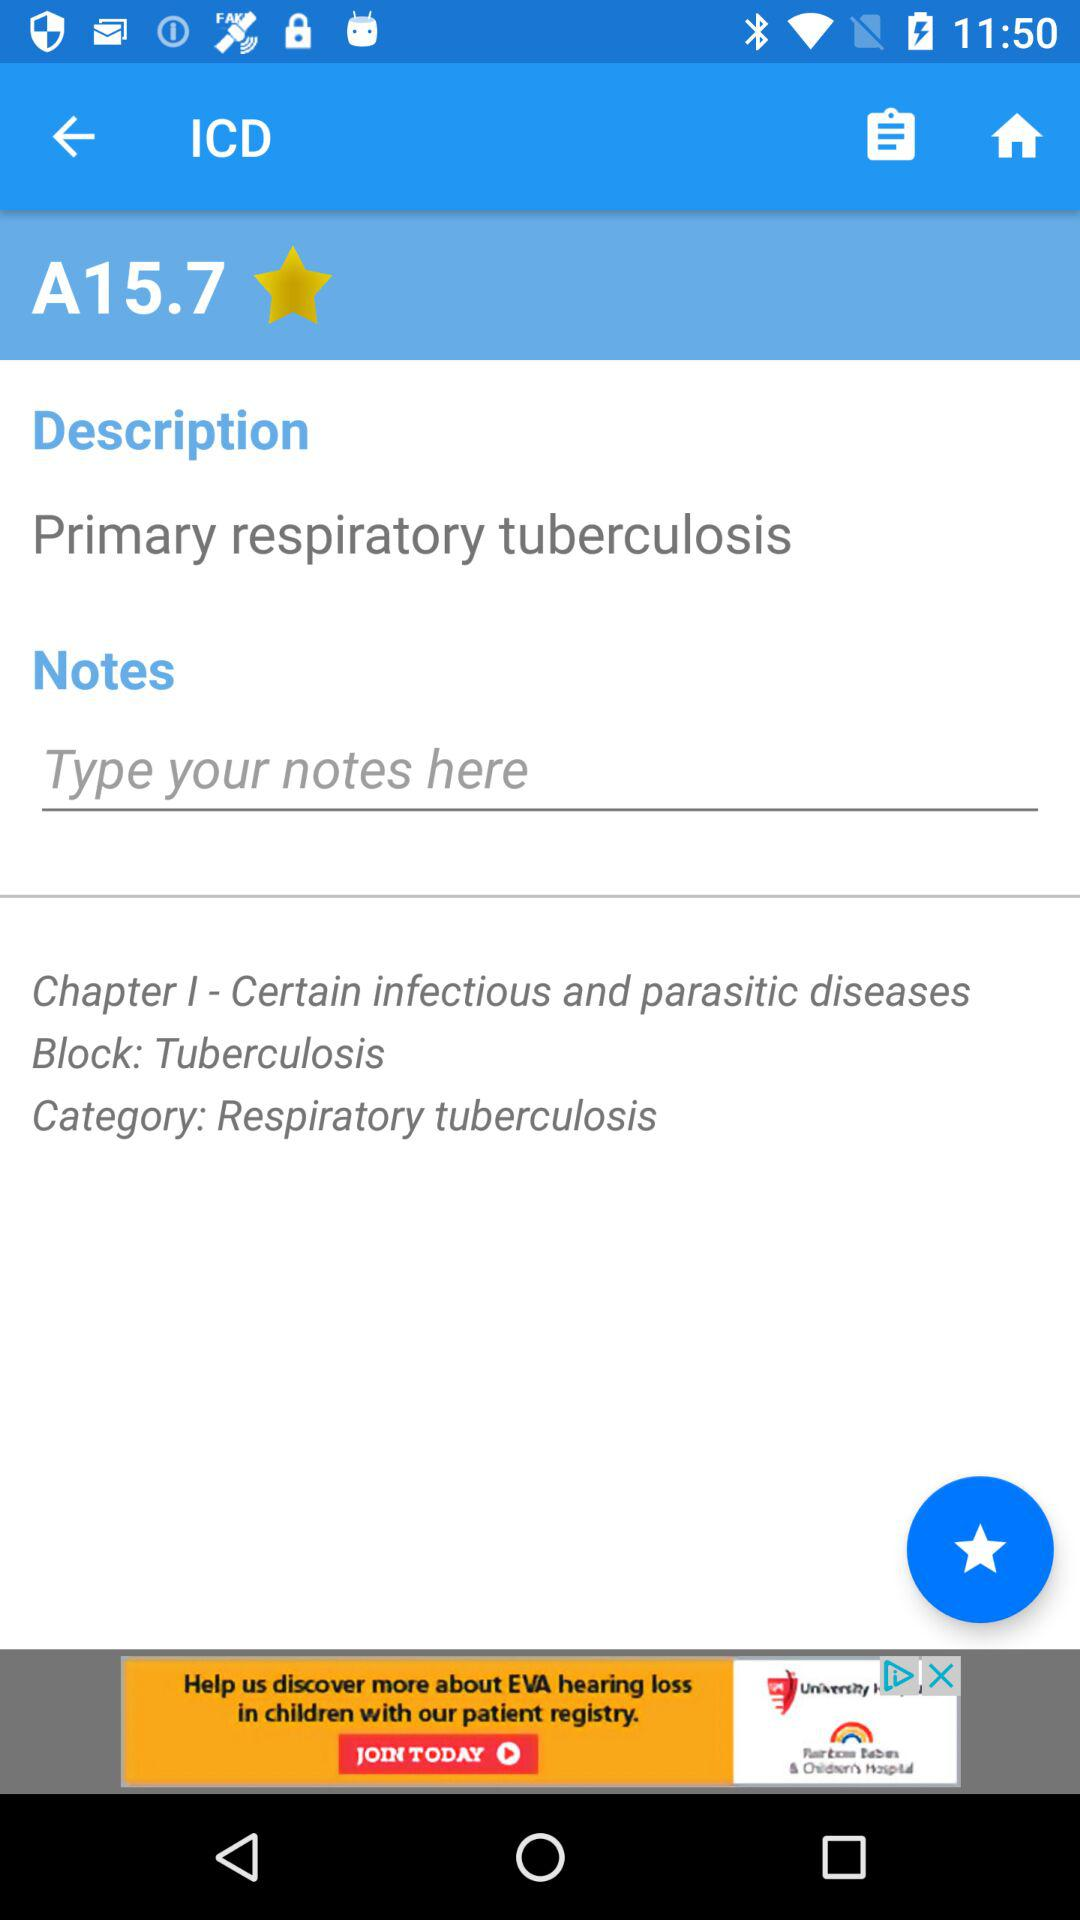What is the category? The category is "Respiratory tuberculosis". 